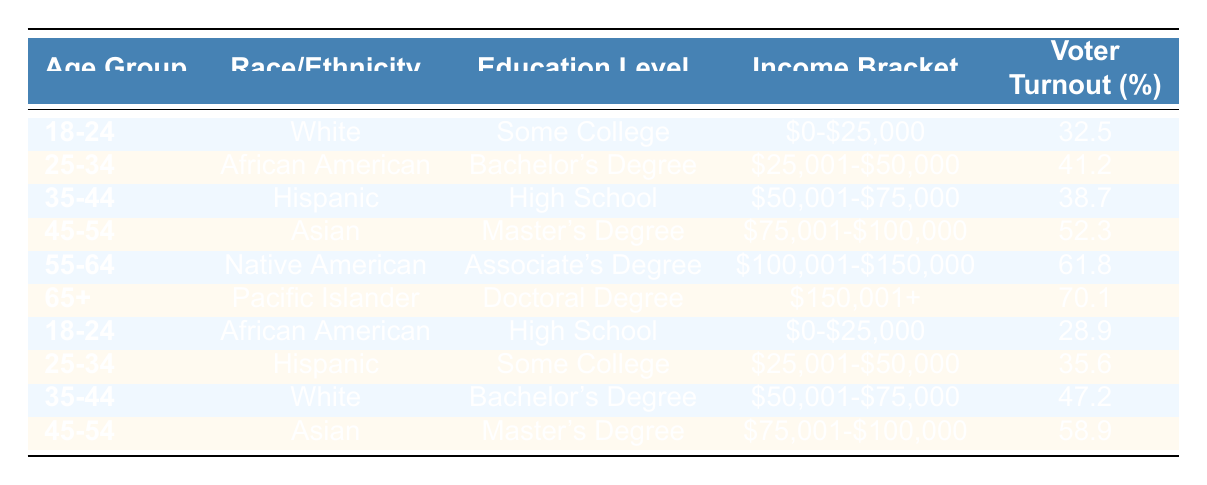What is the voter turnout percentage for the age group 55-64? Referring to the table, under the age group 55-64, the voter turnout percentage is directly listed as 61.8.
Answer: 61.8 Which education level has the highest voter turnout percentage? To find the highest voter turnout, we can compare all the percentages listed: 32.5, 41.2, 38.7, 52.3, 61.8, 70.1, 28.9, 35.6, 47.2, 58.9. The highest is 70.1 for those with a Doctoral Degree.
Answer: Doctoral Degree Is the voter turnout percentage for African American under 25-34 age group greater than for the Hispanic under 25-34 age group? The voter turnout percentage for African American in the 25-34 age group is 41.2, while for Hispanic in the same age group it is 35.6. Since 41.2 is greater than 35.6, the answer is yes.
Answer: Yes What is the difference in voter turnout between the 18-24 age group for White with Some College and African American with High School? Voter turnout for White in the 18-24 group is 32.5, and for African American in the same age group is 28.9. To find the difference: 32.5 - 28.9 = 3.6.
Answer: 3.6 How does the voter turnout for the age group 65+ compare with both 55-64 and 45-54 age groups in percentages? The voter turnout for age group 65+ is 70.1, for 55-64 it is 61.8, and for 45-54 it is 52.3. In comparison, 70.1 is higher than both 61.8 and 52.3, indicating that 65+ has the highest turnout of these groups.
Answer: 65+ is higher than both 